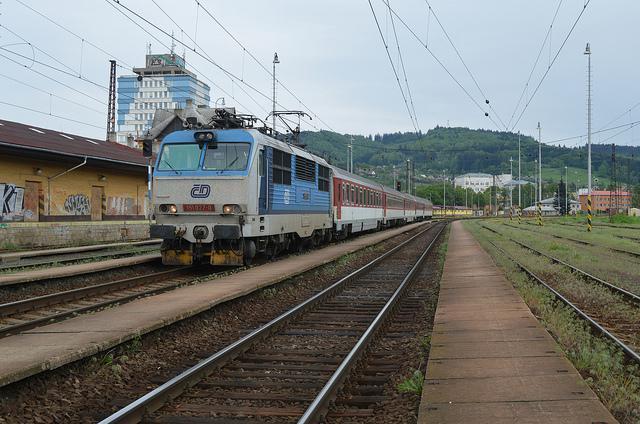How many tracks are visible?
Give a very brief answer. 4. How many women are wearing white?
Give a very brief answer. 0. 